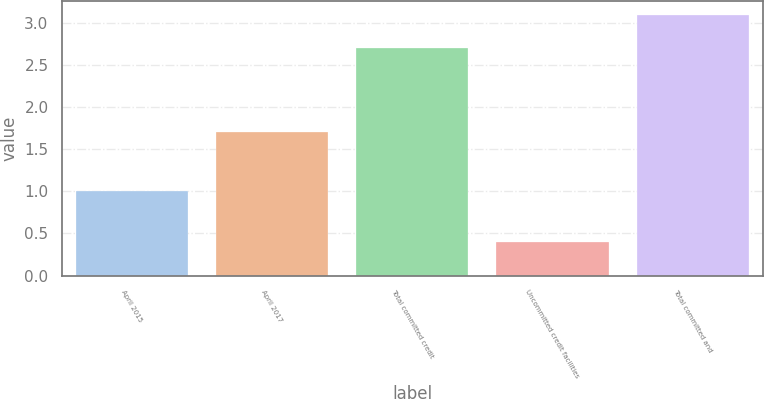Convert chart to OTSL. <chart><loc_0><loc_0><loc_500><loc_500><bar_chart><fcel>April 2015<fcel>April 2017<fcel>Total committed credit<fcel>Uncommitted credit facilities<fcel>Total committed and<nl><fcel>1<fcel>1.7<fcel>2.7<fcel>0.4<fcel>3.1<nl></chart> 